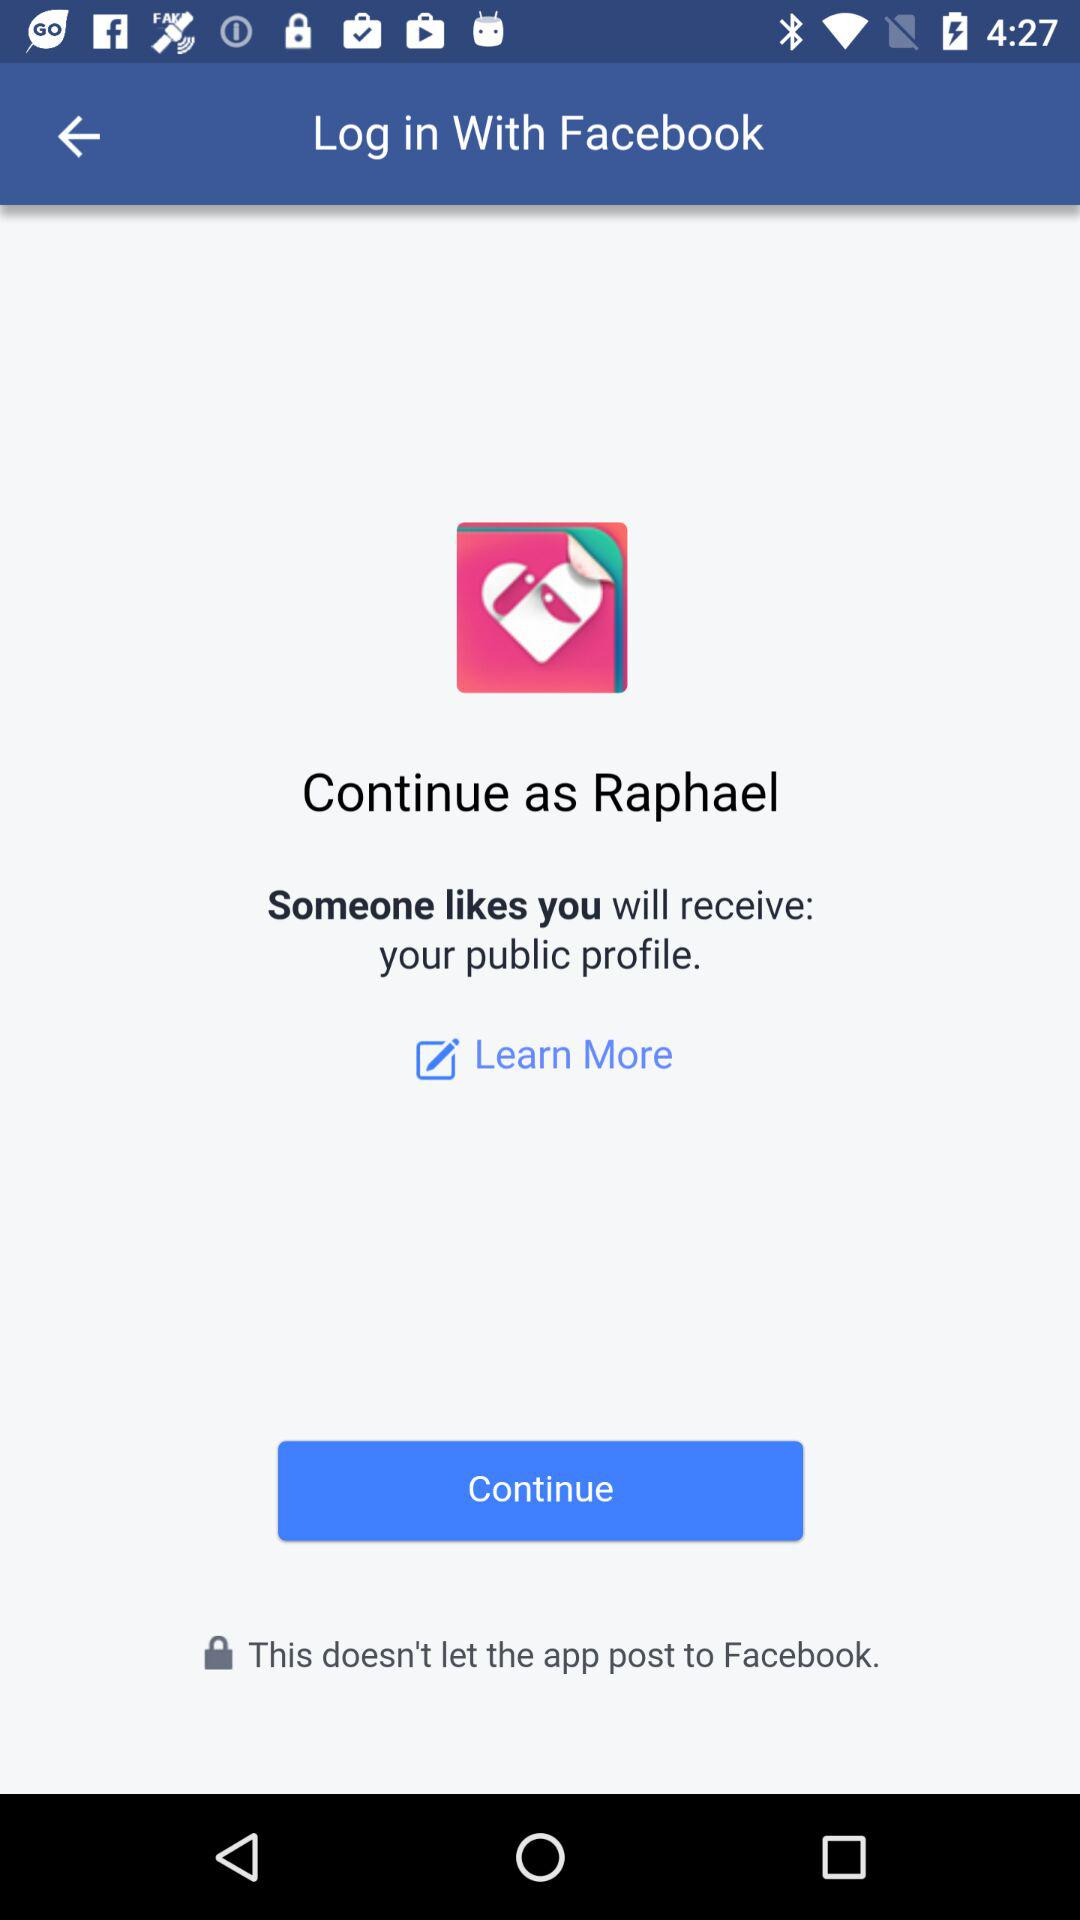What is the user name? The user name is Raphael. 